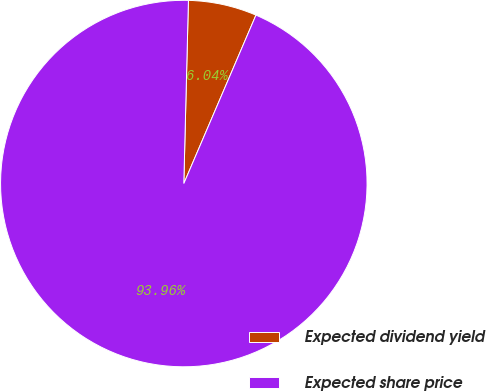Convert chart to OTSL. <chart><loc_0><loc_0><loc_500><loc_500><pie_chart><fcel>Expected dividend yield<fcel>Expected share price<nl><fcel>6.04%<fcel>93.96%<nl></chart> 